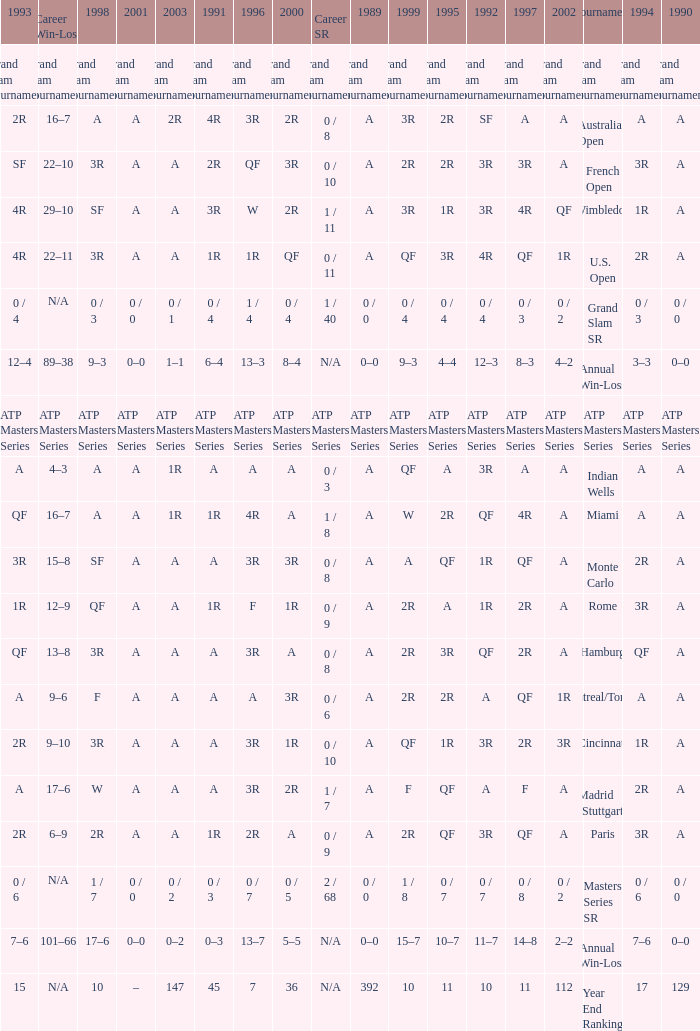What was the value in 1989 with QF in 1997 and A in 1993? A. 